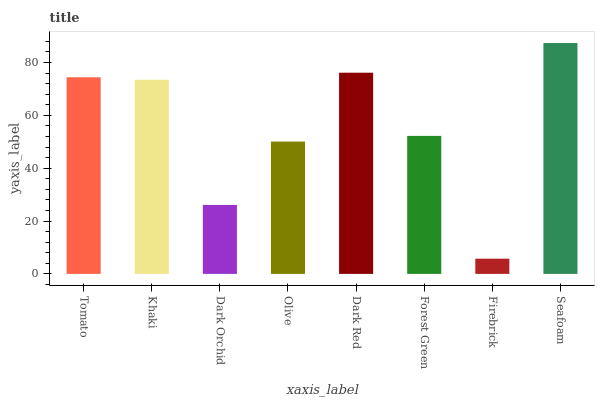Is Firebrick the minimum?
Answer yes or no. Yes. Is Seafoam the maximum?
Answer yes or no. Yes. Is Khaki the minimum?
Answer yes or no. No. Is Khaki the maximum?
Answer yes or no. No. Is Tomato greater than Khaki?
Answer yes or no. Yes. Is Khaki less than Tomato?
Answer yes or no. Yes. Is Khaki greater than Tomato?
Answer yes or no. No. Is Tomato less than Khaki?
Answer yes or no. No. Is Khaki the high median?
Answer yes or no. Yes. Is Forest Green the low median?
Answer yes or no. Yes. Is Tomato the high median?
Answer yes or no. No. Is Olive the low median?
Answer yes or no. No. 